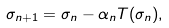<formula> <loc_0><loc_0><loc_500><loc_500>\sigma _ { n + 1 } = \sigma _ { n } - \alpha _ { n } T ( \sigma _ { n } ) ,</formula> 